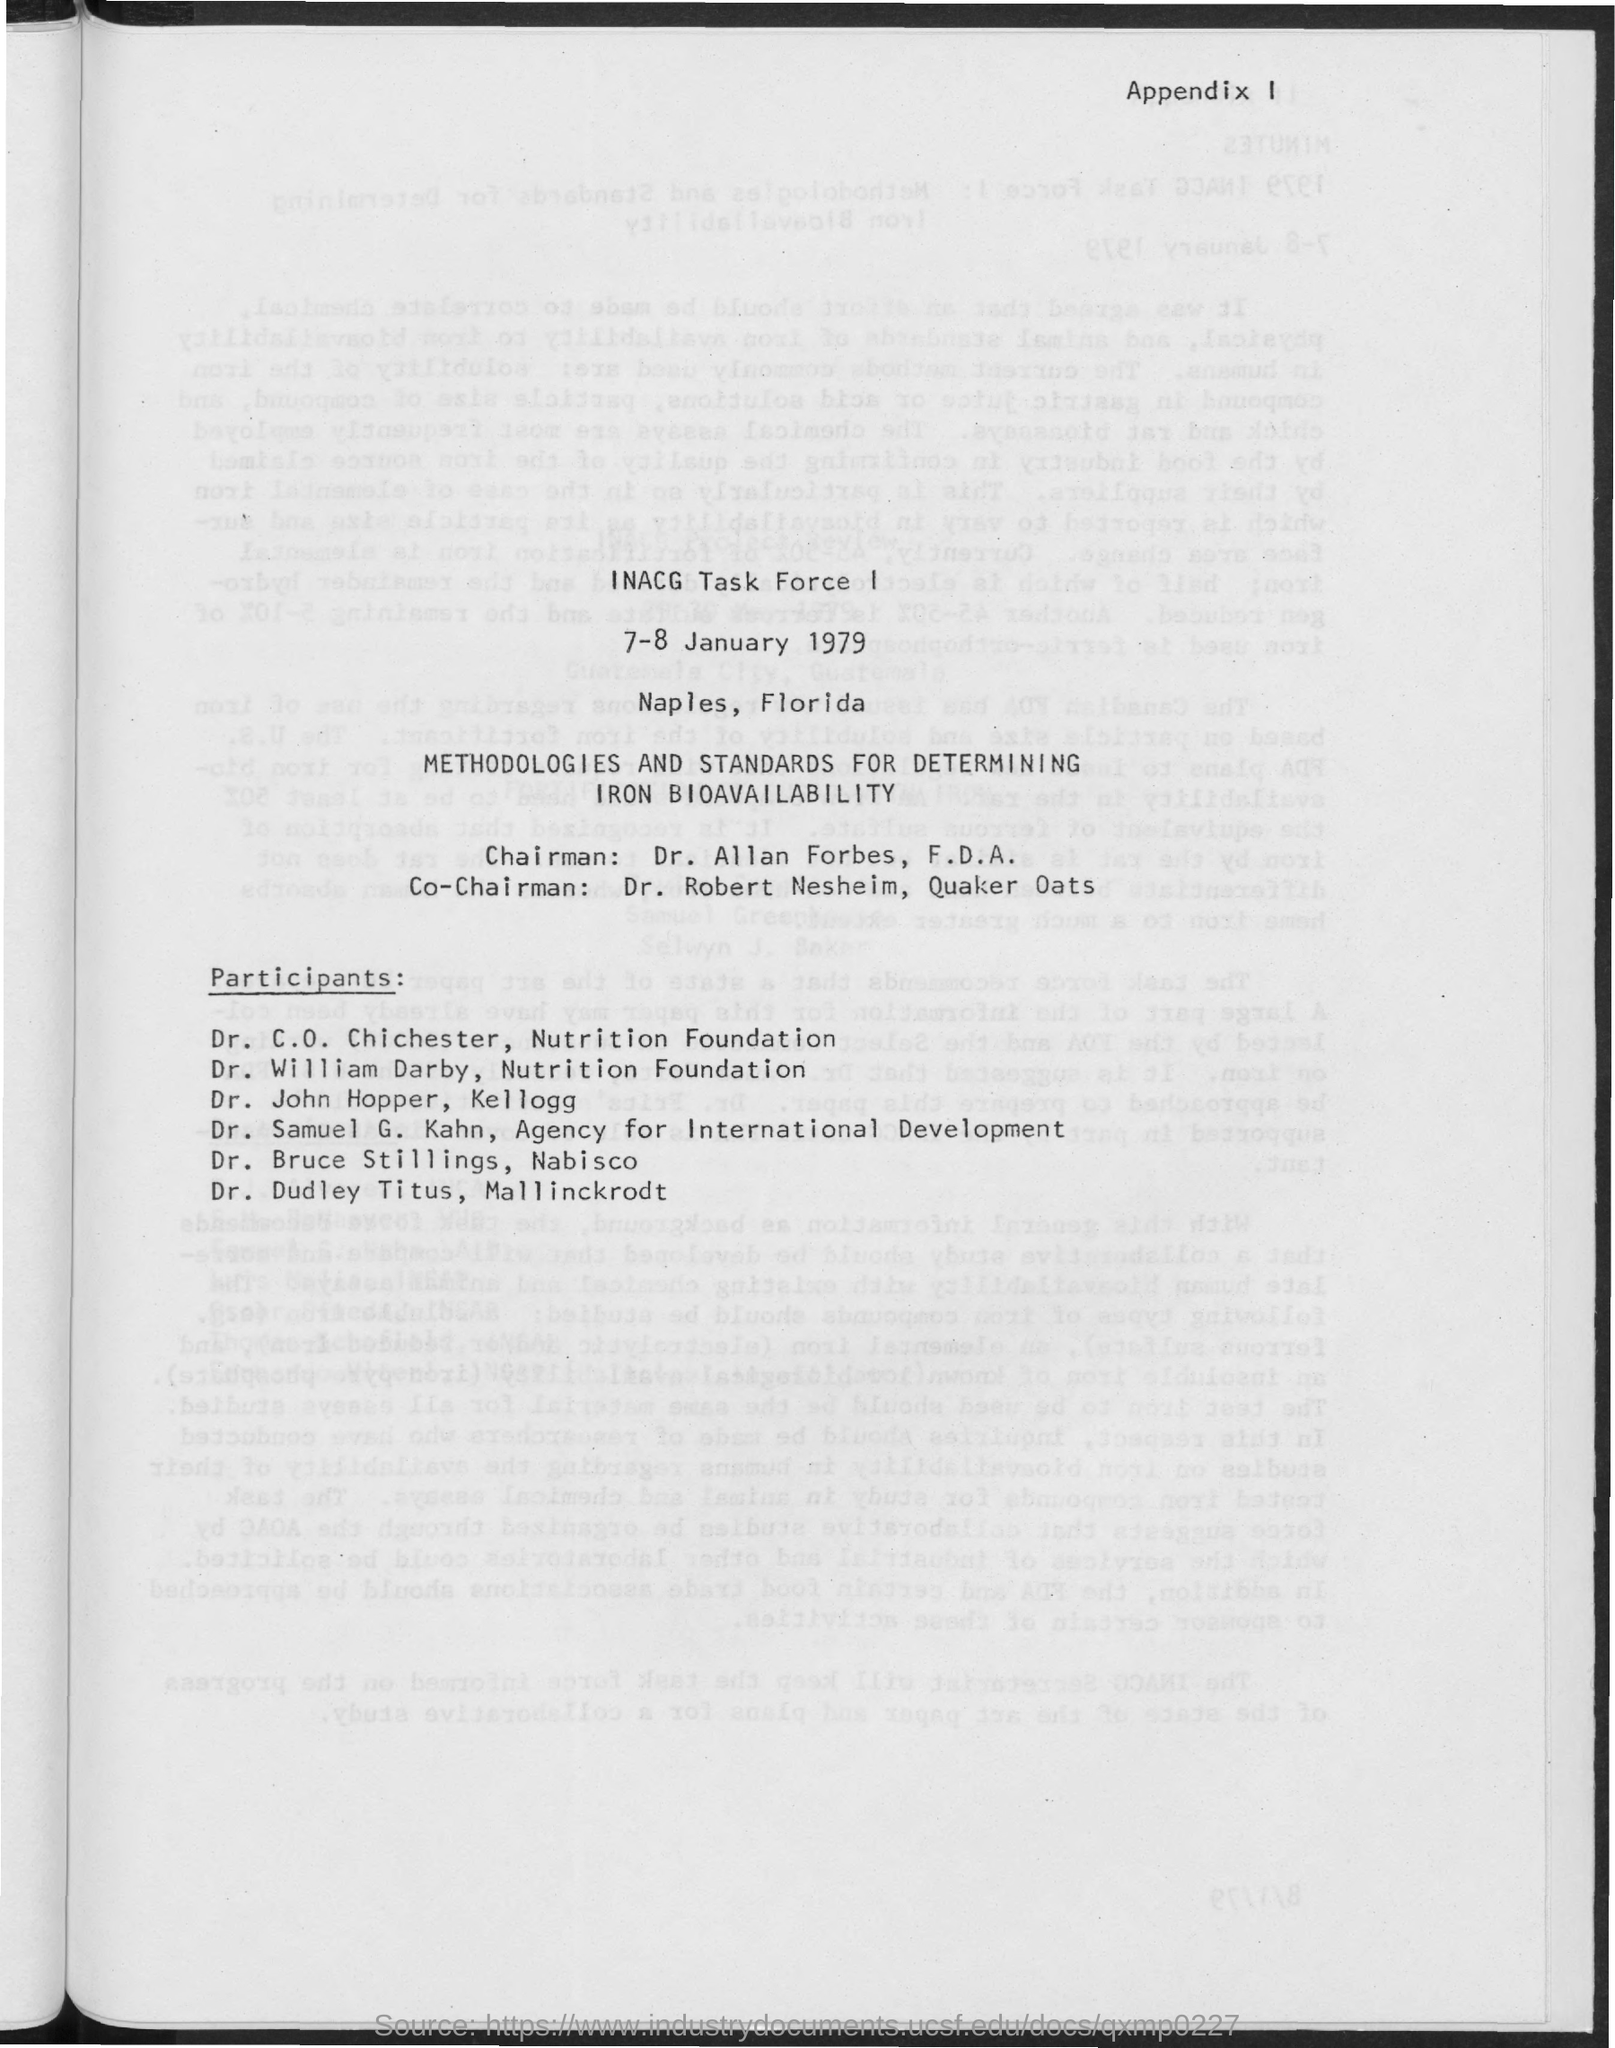Outline some significant characteristics in this image. The name of the chairman mentioned in the document is Dr. Allan Forbes. Dr. Robert Nesheim is the co-chairman of Quaker Oats. 